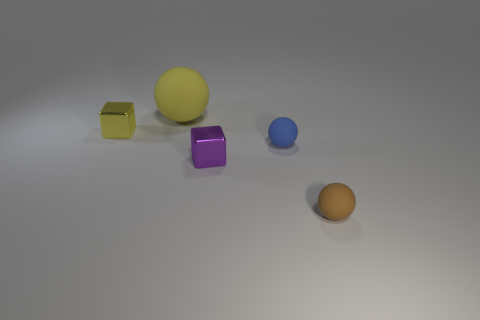Is there anything else that has the same size as the yellow rubber ball?
Your answer should be compact. No. The other brown matte thing that is the same shape as the big rubber object is what size?
Keep it short and to the point. Small. There is a shiny thing that is on the right side of the big yellow rubber ball; is its shape the same as the brown matte object?
Keep it short and to the point. No. What is the shape of the small shiny thing on the right side of the small metallic block that is on the left side of the purple cube?
Offer a terse response. Cube. Are there any other things that have the same shape as the small blue object?
Your answer should be compact. Yes. There is another tiny rubber thing that is the same shape as the small blue thing; what is its color?
Provide a short and direct response. Brown. Do the large rubber thing and the tiny metallic cube on the right side of the small yellow cube have the same color?
Ensure brevity in your answer.  No. The small object that is both on the left side of the small brown thing and right of the purple metal block has what shape?
Keep it short and to the point. Sphere. Is the number of brown spheres less than the number of tiny shiny things?
Your answer should be very brief. Yes. Are there any green matte blocks?
Ensure brevity in your answer.  No. 